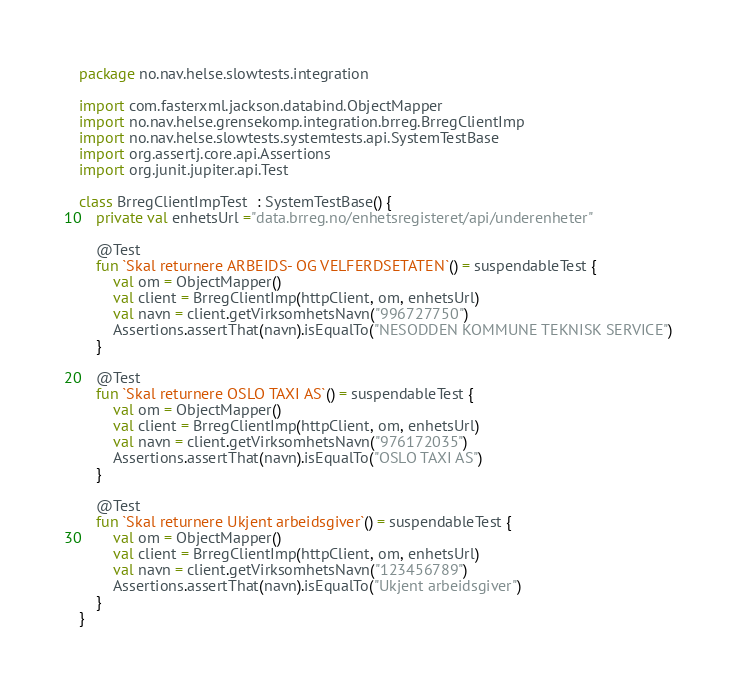Convert code to text. <code><loc_0><loc_0><loc_500><loc_500><_Kotlin_>package no.nav.helse.slowtests.integration

import com.fasterxml.jackson.databind.ObjectMapper
import no.nav.helse.grensekomp.integration.brreg.BrregClientImp
import no.nav.helse.slowtests.systemtests.api.SystemTestBase
import org.assertj.core.api.Assertions
import org.junit.jupiter.api.Test

class BrregClientImpTest  : SystemTestBase() {
    private val enhetsUrl ="data.brreg.no/enhetsregisteret/api/underenheter"

    @Test
    fun `Skal returnere ARBEIDS- OG VELFERDSETATEN`() = suspendableTest {
        val om = ObjectMapper()
        val client = BrregClientImp(httpClient, om, enhetsUrl)
        val navn = client.getVirksomhetsNavn("996727750")
        Assertions.assertThat(navn).isEqualTo("NESODDEN KOMMUNE TEKNISK SERVICE")
    }

    @Test
    fun `Skal returnere OSLO TAXI AS`() = suspendableTest {
        val om = ObjectMapper()
        val client = BrregClientImp(httpClient, om, enhetsUrl)
        val navn = client.getVirksomhetsNavn("976172035")
        Assertions.assertThat(navn).isEqualTo("OSLO TAXI AS")
    }

    @Test
    fun `Skal returnere Ukjent arbeidsgiver`() = suspendableTest {
        val om = ObjectMapper()
        val client = BrregClientImp(httpClient, om, enhetsUrl)
        val navn = client.getVirksomhetsNavn("123456789")
        Assertions.assertThat(navn).isEqualTo("Ukjent arbeidsgiver")
    }
}

</code> 